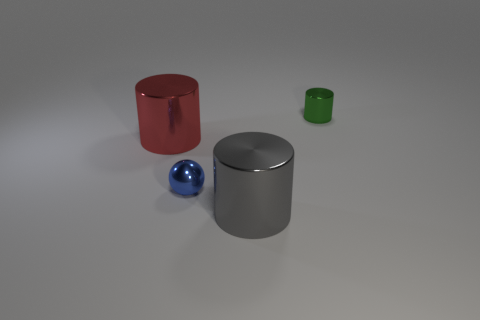How many things are either big brown objects or tiny blue things that are on the right side of the red metallic cylinder? There is one small blue sphere on the right side of the red metallic cylinder. There are no big brown objects in the image. 